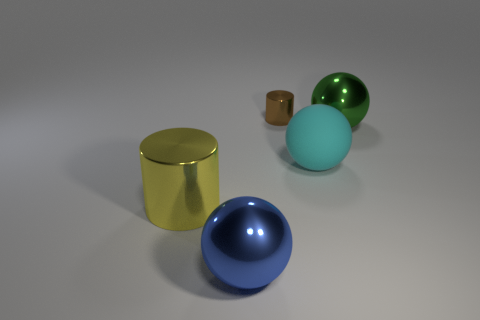Can you describe the lighting of this scene? The lighting in the image is soft and diffused, originating from a direction above the objects, which creates subtle shadows on the ground beneath each item. This suggests an indoor setting, possibly lit by a single overhead light source. Does the lighting add anything to the image? Yes, the gentle lighting highlights the reflective qualities of the objects, emphasizes their shapes, and enhances the visual textures. It also creates a serene, almost studio-like atmosphere. 